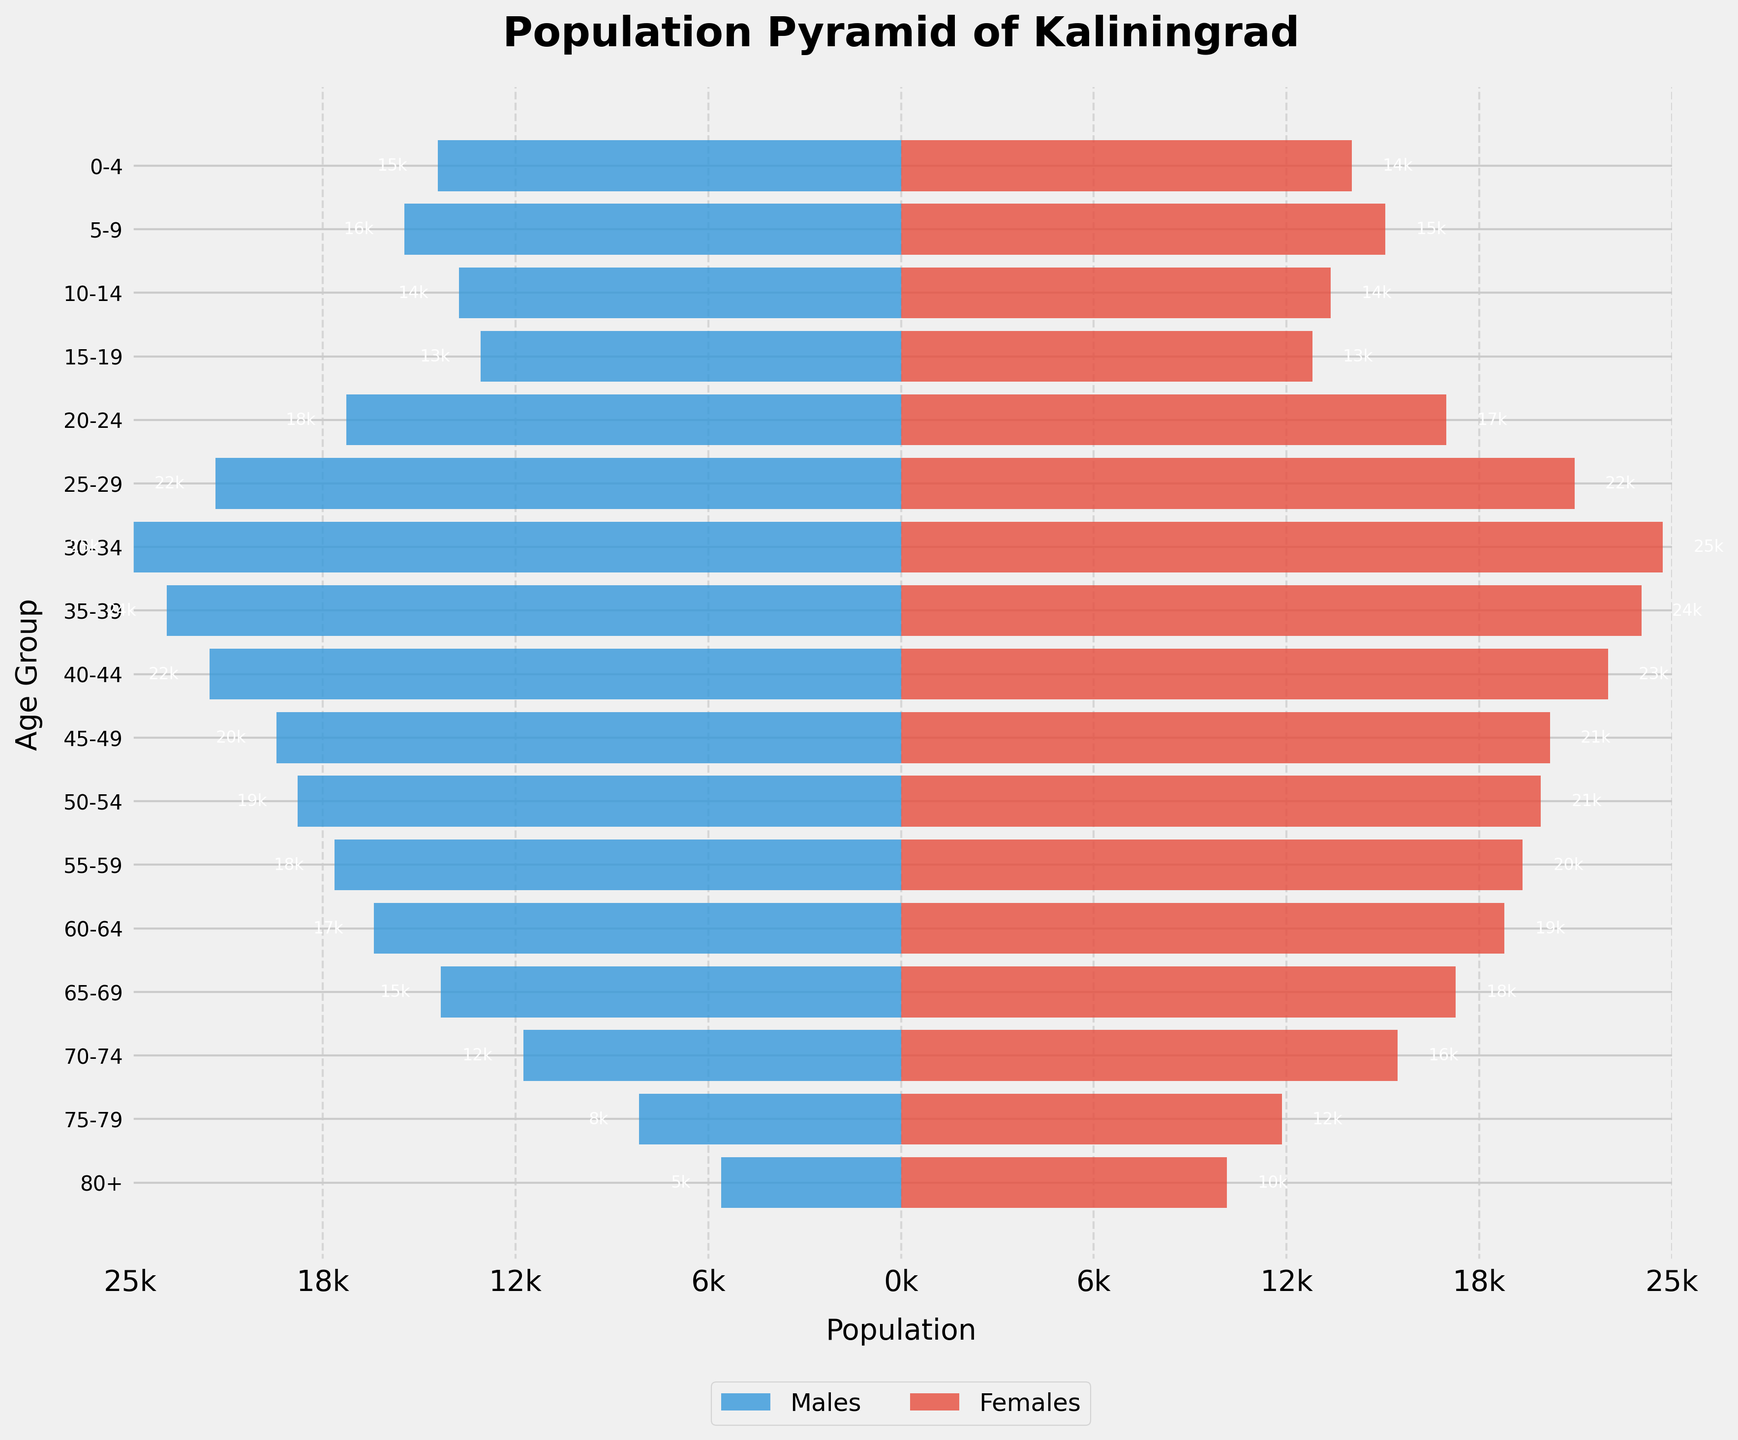What is the title of the plot? The title is displayed at the top of the figure in bold. It summarizes what the plot is about. In this case, it reads "Population Pyramid of Kaliningrad."
Answer: Population Pyramid of Kaliningrad Which gender has a higher population in the age group 30-34? By observing the plot, specifically the bars for the age group 30-34, we can see which side (left for males or right for females) extends further. In this case, the bars are almost equal, but the male's bar is slightly longer than the female's bar.
Answer: Males What's the range of the population for the age group 15-19? For this age group, we look for the extent of the bars for both males and females. The males have a population of 13,800 and females have 13,500. The range is the difference between the highest and the lowest number.
Answer: 300 Which age group has the smallest female population? By comparing the lengths of the bars on the right side (for females), the age group with the shortest bar represents the smallest population. The age group 80+ has the shortest female bar.
Answer: 80+ What's the combined population of males and females in the age group 25-29? Adding the male population of 22,500 and the female population of 22,100 for this age group, we get the total. This involves a simple addition operation: 22,500 + 22,100 = 44,600.
Answer: 44,600 Which gender has more voting-age individuals (18+)? We sum up the populations of males and females for age groups from 18 and above (in this case, from 20-24 to 80+ due to the provided groups). For males, it's (-18,200 - 22,500 - 25,300 - 24,100 - 22,700 - 20,500 - 19,800 - 18,600 - 17,300 - 15,100 - 12,400 - 8,600 - 5,900) and for females it's (17,900 + 22,100 + 25,000 + 24,300 + 23,200 + 21,300 + 21,000 + 20,400 + 19,800 + 18,200 + 16,300 + 12,500 + 10,700). After summing them up, we compare the totals. The calculation clearly shows that females have a higher total.
Answer: Females What percentage of the population in the 75-79 age group is female? The total population for the 75-79 age group is the sum of males and females: 8,600 + 12,500 = 21,100. The percentage is calculated as (female population / total population) * 100, which is (12,500 / 21,100) * 100. This evaluates to approximately 59.24%.
Answer: 59.24% Which two adjacent age groups have the most significant drop in the population for males? We compare the drops in male population between consecutive age groups by subtracting the population of the younger group from the older one. The biggest drop occurs in moving from 65-69 (15,100) to 70-74 (12,400). The difference is 2,700.
Answer: 65-69 to 70-74 In which age group is the gender ratio most skewed towards females? By examining the bars and calculating the difference in population between females and males for each age group, the age group with the largest difference will show where the skew is most significant. The age group is 80+, where females (10,700) vastly outnumber males (5,900).
Answer: 80+ Is there any age group where the number of males is almost equal to the number of females? We look for the age group where the bars for males and females are closely aligned without a large visible difference. For the age group 35-39, males (24,100) and females (24,300) have nearly equal populations, differing by only 200.
Answer: 35-39 